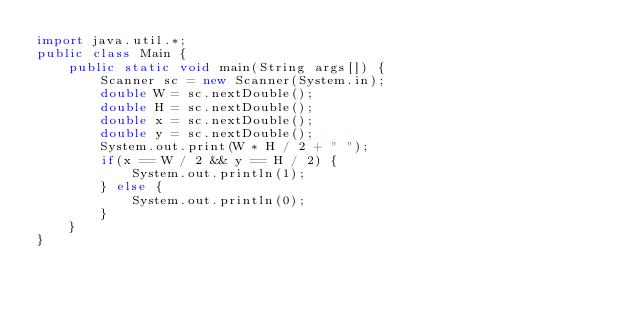<code> <loc_0><loc_0><loc_500><loc_500><_Java_>import java.util.*;
public class Main {
	public static void main(String args[]) {
		Scanner sc = new Scanner(System.in);
		double W = sc.nextDouble();
		double H = sc.nextDouble();
		double x = sc.nextDouble();
		double y = sc.nextDouble();
		System.out.print(W * H / 2 + " ");
		if(x == W / 2 && y == H / 2) {
			System.out.println(1);
		} else {
			System.out.println(0);
		}
	}
}
</code> 